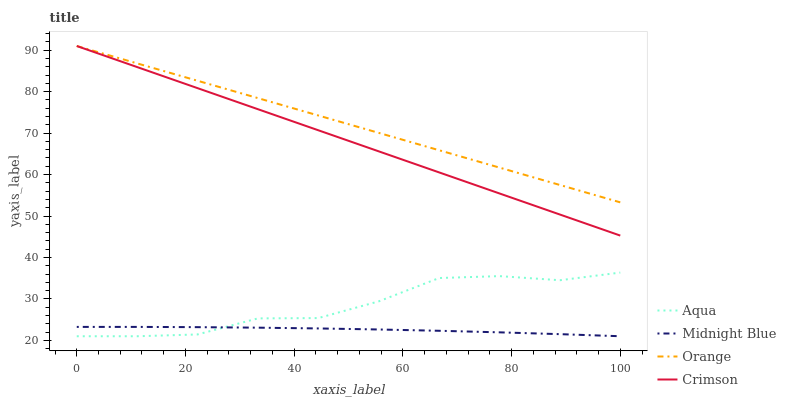Does Midnight Blue have the minimum area under the curve?
Answer yes or no. Yes. Does Orange have the maximum area under the curve?
Answer yes or no. Yes. Does Crimson have the minimum area under the curve?
Answer yes or no. No. Does Crimson have the maximum area under the curve?
Answer yes or no. No. Is Crimson the smoothest?
Answer yes or no. Yes. Is Aqua the roughest?
Answer yes or no. Yes. Is Aqua the smoothest?
Answer yes or no. No. Is Crimson the roughest?
Answer yes or no. No. Does Aqua have the lowest value?
Answer yes or no. Yes. Does Crimson have the lowest value?
Answer yes or no. No. Does Crimson have the highest value?
Answer yes or no. Yes. Does Aqua have the highest value?
Answer yes or no. No. Is Aqua less than Crimson?
Answer yes or no. Yes. Is Orange greater than Aqua?
Answer yes or no. Yes. Does Aqua intersect Midnight Blue?
Answer yes or no. Yes. Is Aqua less than Midnight Blue?
Answer yes or no. No. Is Aqua greater than Midnight Blue?
Answer yes or no. No. Does Aqua intersect Crimson?
Answer yes or no. No. 